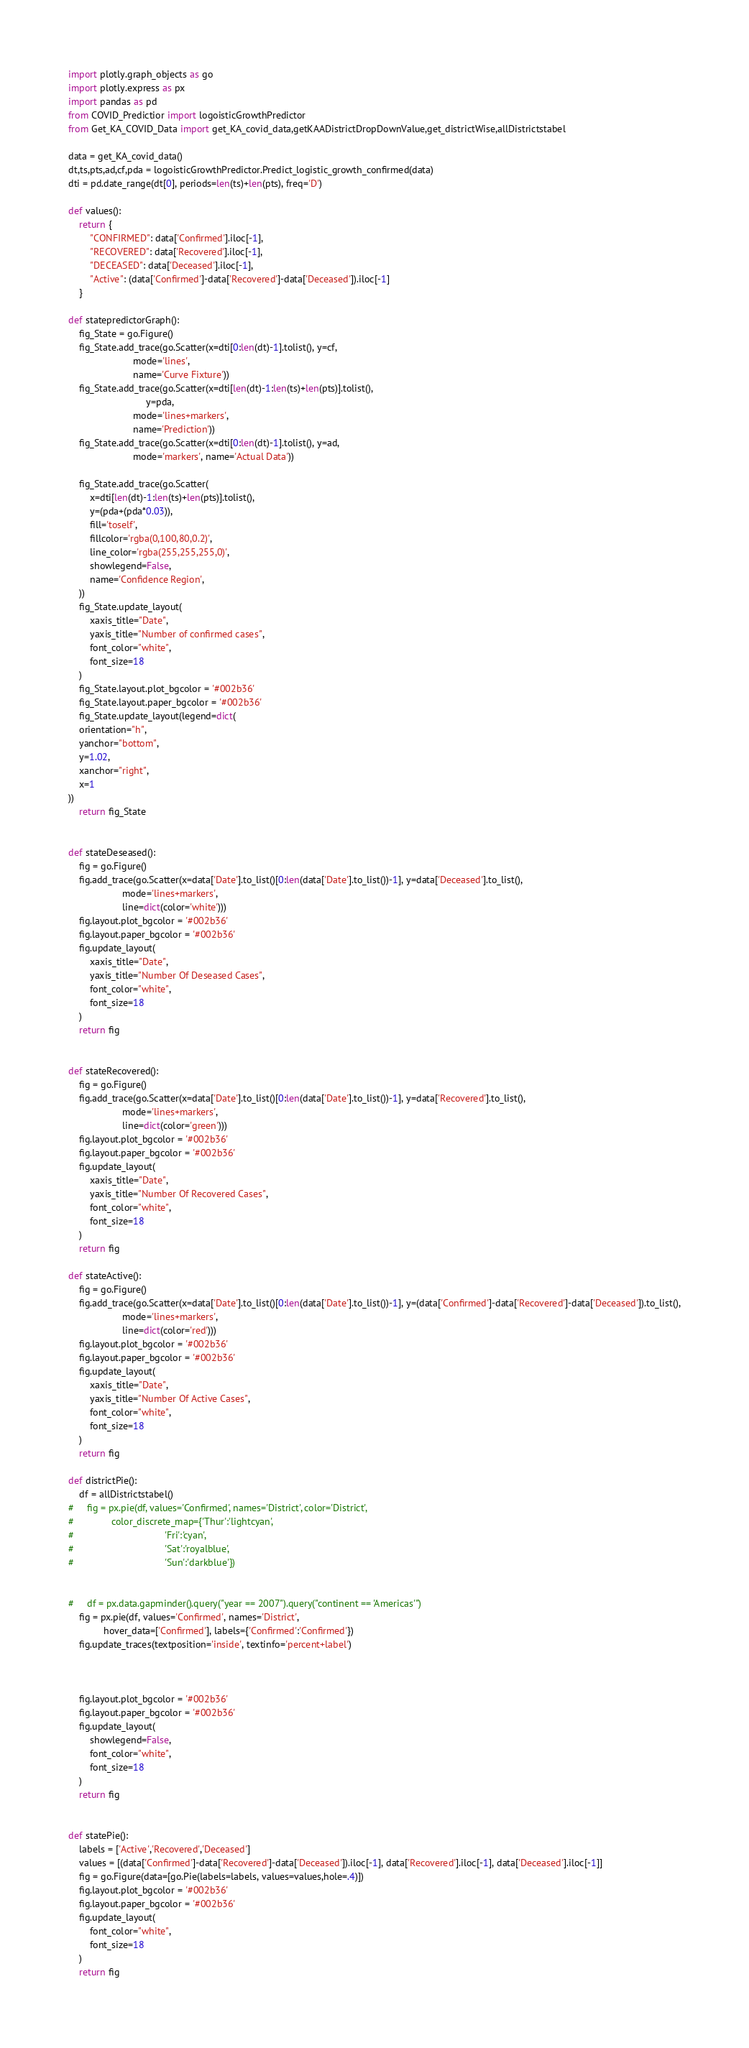<code> <loc_0><loc_0><loc_500><loc_500><_Python_>import plotly.graph_objects as go
import plotly.express as px
import pandas as pd
from COVID_Predictior import logoisticGrowthPredictor
from Get_KA_COVID_Data import get_KA_covid_data,getKAADistrictDropDownValue,get_districtWise,allDistrictstabel

data = get_KA_covid_data()
dt,ts,pts,ad,cf,pda = logoisticGrowthPredictor.Predict_logistic_growth_confirmed(data)
dti = pd.date_range(dt[0], periods=len(ts)+len(pts), freq='D')

def values():
    return {
        "CONFIRMED": data['Confirmed'].iloc[-1],
        "RECOVERED": data['Recovered'].iloc[-1],
        "DECEASED": data['Deceased'].iloc[-1],
        "Active": (data['Confirmed']-data['Recovered']-data['Deceased']).iloc[-1]
    }

def statepredictorGraph():
    fig_State = go.Figure()
    fig_State.add_trace(go.Scatter(x=dti[0:len(dt)-1].tolist(), y=cf,
                        mode='lines',
                        name='Curve Fixture'))
    fig_State.add_trace(go.Scatter(x=dti[len(dt)-1:len(ts)+len(pts)].tolist(),
                             y=pda,
                        mode='lines+markers',
                        name='Prediction'))
    fig_State.add_trace(go.Scatter(x=dti[0:len(dt)-1].tolist(), y=ad,
                        mode='markers', name='Actual Data'))

    fig_State.add_trace(go.Scatter(
        x=dti[len(dt)-1:len(ts)+len(pts)].tolist(),
        y=(pda+(pda*0.03)),
        fill='toself',
        fillcolor='rgba(0,100,80,0.2)',
        line_color='rgba(255,255,255,0)',
        showlegend=False,
        name='Confidence Region',
    ))
    fig_State.update_layout(
        xaxis_title="Date",
        yaxis_title="Number of confirmed cases",
        font_color="white",
        font_size=18
    )
    fig_State.layout.plot_bgcolor = '#002b36'
    fig_State.layout.paper_bgcolor = '#002b36'
    fig_State.update_layout(legend=dict(
    orientation="h",
    yanchor="bottom",
    y=1.02,
    xanchor="right",
    x=1
))
    return fig_State


def stateDeseased():
    fig = go.Figure()
    fig.add_trace(go.Scatter(x=data['Date'].to_list()[0:len(data['Date'].to_list())-1], y=data['Deceased'].to_list(),
                    mode='lines+markers',
                    line=dict(color='white')))
    fig.layout.plot_bgcolor = '#002b36'
    fig.layout.paper_bgcolor = '#002b36'
    fig.update_layout(
        xaxis_title="Date",
        yaxis_title="Number Of Deseased Cases",
        font_color="white",
        font_size=18
    )
    return fig


def stateRecovered():
    fig = go.Figure()
    fig.add_trace(go.Scatter(x=data['Date'].to_list()[0:len(data['Date'].to_list())-1], y=data['Recovered'].to_list(),
                    mode='lines+markers',
                    line=dict(color='green')))
    fig.layout.plot_bgcolor = '#002b36'
    fig.layout.paper_bgcolor = '#002b36'
    fig.update_layout(
        xaxis_title="Date",
        yaxis_title="Number Of Recovered Cases",
        font_color="white",
        font_size=18
    )
    return fig

def stateActive():
    fig = go.Figure()
    fig.add_trace(go.Scatter(x=data['Date'].to_list()[0:len(data['Date'].to_list())-1], y=(data['Confirmed']-data['Recovered']-data['Deceased']).to_list(),
                    mode='lines+markers',
                    line=dict(color='red')))
    fig.layout.plot_bgcolor = '#002b36'
    fig.layout.paper_bgcolor = '#002b36'
    fig.update_layout(
        xaxis_title="Date",
        yaxis_title="Number Of Active Cases",
        font_color="white",
        font_size=18
    )
    return fig

def districtPie():
    df = allDistrictstabel()
#     fig = px.pie(df, values='Confirmed', names='District', color='District',
#              color_discrete_map={'Thur':'lightcyan',
#                                  'Fri':'cyan',
#                                  'Sat':'royalblue',
#                                  'Sun':'darkblue'})
    
    
#     df = px.data.gapminder().query("year == 2007").query("continent == 'Americas'")
    fig = px.pie(df, values='Confirmed', names='District',
             hover_data=['Confirmed'], labels={'Confirmed':'Confirmed'})
    fig.update_traces(textposition='inside', textinfo='percent+label')
    
    
    
    fig.layout.plot_bgcolor = '#002b36'
    fig.layout.paper_bgcolor = '#002b36'
    fig.update_layout(
        showlegend=False,
        font_color="white",
        font_size=18
    )
    return fig


def statePie():
    labels = ['Active','Recovered','Deceased']
    values = [(data['Confirmed']-data['Recovered']-data['Deceased']).iloc[-1], data['Recovered'].iloc[-1], data['Deceased'].iloc[-1]]
    fig = go.Figure(data=[go.Pie(labels=labels, values=values,hole=.4)])
    fig.layout.plot_bgcolor = '#002b36'
    fig.layout.paper_bgcolor = '#002b36'
    fig.update_layout(
        font_color="white",
        font_size=18
    )
    return fig</code> 